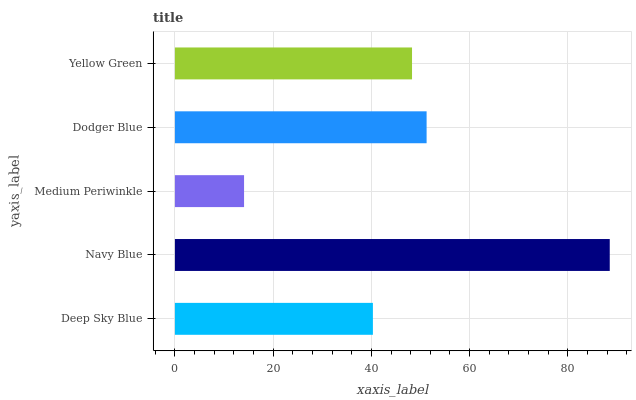Is Medium Periwinkle the minimum?
Answer yes or no. Yes. Is Navy Blue the maximum?
Answer yes or no. Yes. Is Navy Blue the minimum?
Answer yes or no. No. Is Medium Periwinkle the maximum?
Answer yes or no. No. Is Navy Blue greater than Medium Periwinkle?
Answer yes or no. Yes. Is Medium Periwinkle less than Navy Blue?
Answer yes or no. Yes. Is Medium Periwinkle greater than Navy Blue?
Answer yes or no. No. Is Navy Blue less than Medium Periwinkle?
Answer yes or no. No. Is Yellow Green the high median?
Answer yes or no. Yes. Is Yellow Green the low median?
Answer yes or no. Yes. Is Deep Sky Blue the high median?
Answer yes or no. No. Is Medium Periwinkle the low median?
Answer yes or no. No. 